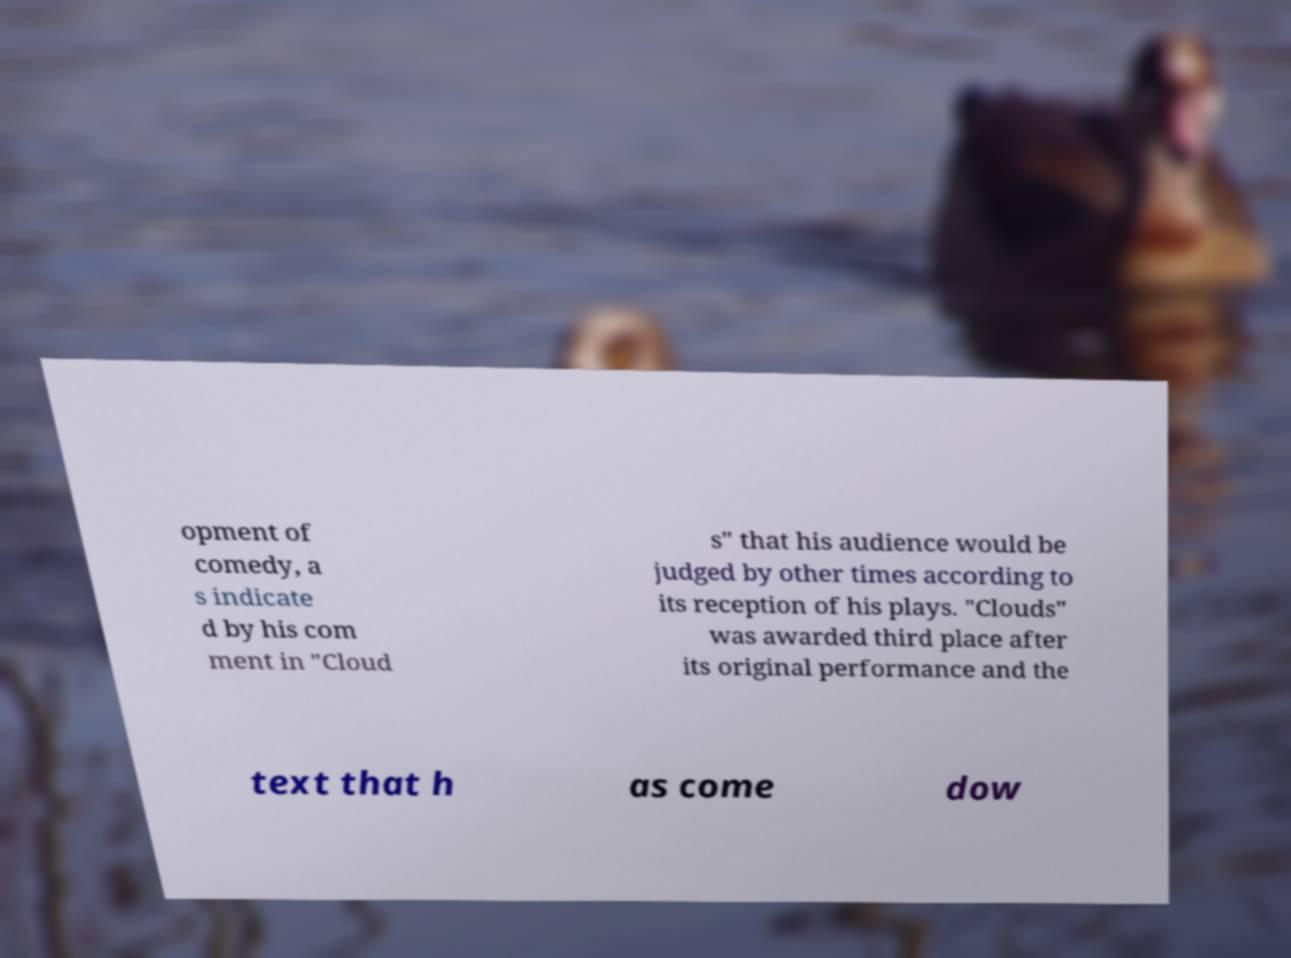Please read and relay the text visible in this image. What does it say? opment of comedy, a s indicate d by his com ment in "Cloud s" that his audience would be judged by other times according to its reception of his plays. "Clouds" was awarded third place after its original performance and the text that h as come dow 